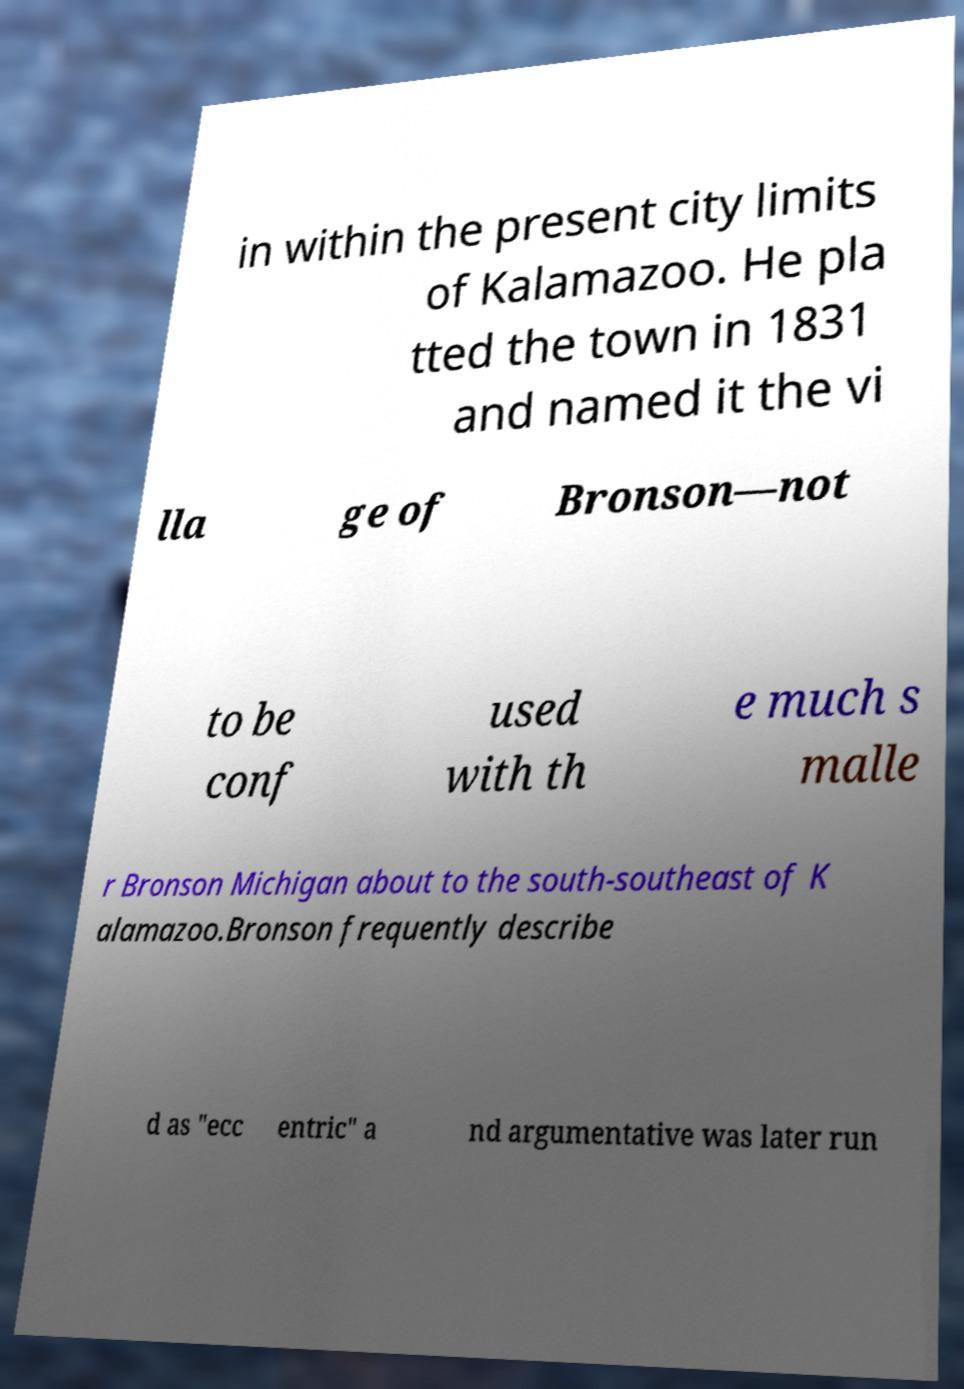For documentation purposes, I need the text within this image transcribed. Could you provide that? in within the present city limits of Kalamazoo. He pla tted the town in 1831 and named it the vi lla ge of Bronson—not to be conf used with th e much s malle r Bronson Michigan about to the south-southeast of K alamazoo.Bronson frequently describe d as "ecc entric" a nd argumentative was later run 